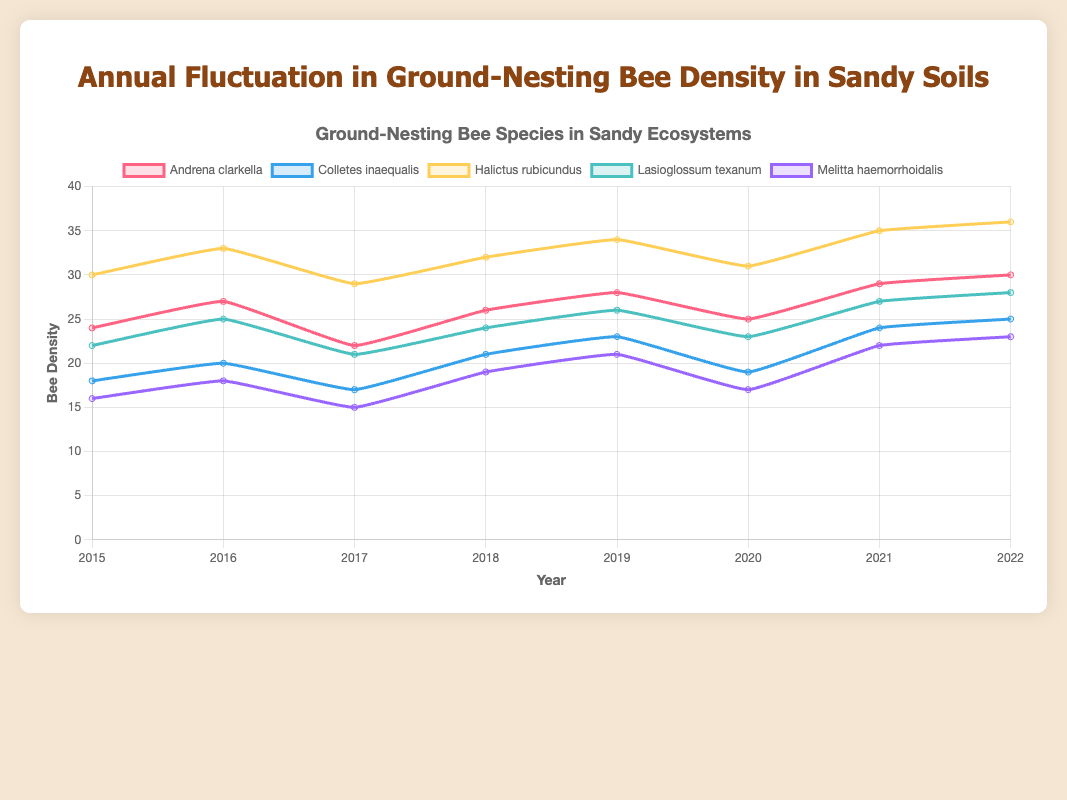Which bee species had the highest density in 2022? By looking at the endpoint of the lines at 2022, we can see that "Halictus rubicundus" has the highest y-value.
Answer: Halictus rubicundus How did the density of Lasioglossum texanum change from 2016 to 2017? Observing the values of Lasioglossum texanum between 2016 and 2017, we see it went from 25 to 21, a decrease of 4.
Answer: Decreased by 4 Which species showed the greatest increase in density between 2015 and 2022? By comparing the first and last values for each species from 2015 to 2022, "Halictus rubicundus" increased from 30 to 36, the largest increase of 6.
Answer: Halictus rubicundus Which species experienced a decrease in density from 2021 to 2022? The slopes for "Colletes inaequalis" and "Melitta haemorrhoidalis" show a drop from 2021 to 2022.
Answer: Colletes inaequalis and Melitta haemorrhoidalis What is the average density of Andrena clarkella over the years? Add the values for Andrena clarkella from each year (24 + 27 + 22 + 26 + 28 + 25 + 29 + 30 = 211) and divide by the number of years (211/8 = 26.375).
Answer: 26.375 Which species had the smallest density in 2017? By observing the values for 2017, "Melitta haemorrhoidalis" had the smallest value at 15.
Answer: Melitta haemorrhoidalis How many species had densities greater than 30 in 2021? By looking at the densities for 2021, "Halictus rubicundus" (35) was greater than 30.
Answer: 1 species Which bee's density remained most stable over the years? Stability can be judged by the least fluctuation. "Melitta haemorrhoidalis" seems to have minor fluctuations in its line.
Answer: Melitta haemorrhoidalis What is the difference in density between Halictus rubicundus and Colletes inaequalis in 2019? Subtract the value for Colletes inaequalis (23) from Halictus rubicundus (34) for 2019 (34 - 23 = 11).
Answer: 11 